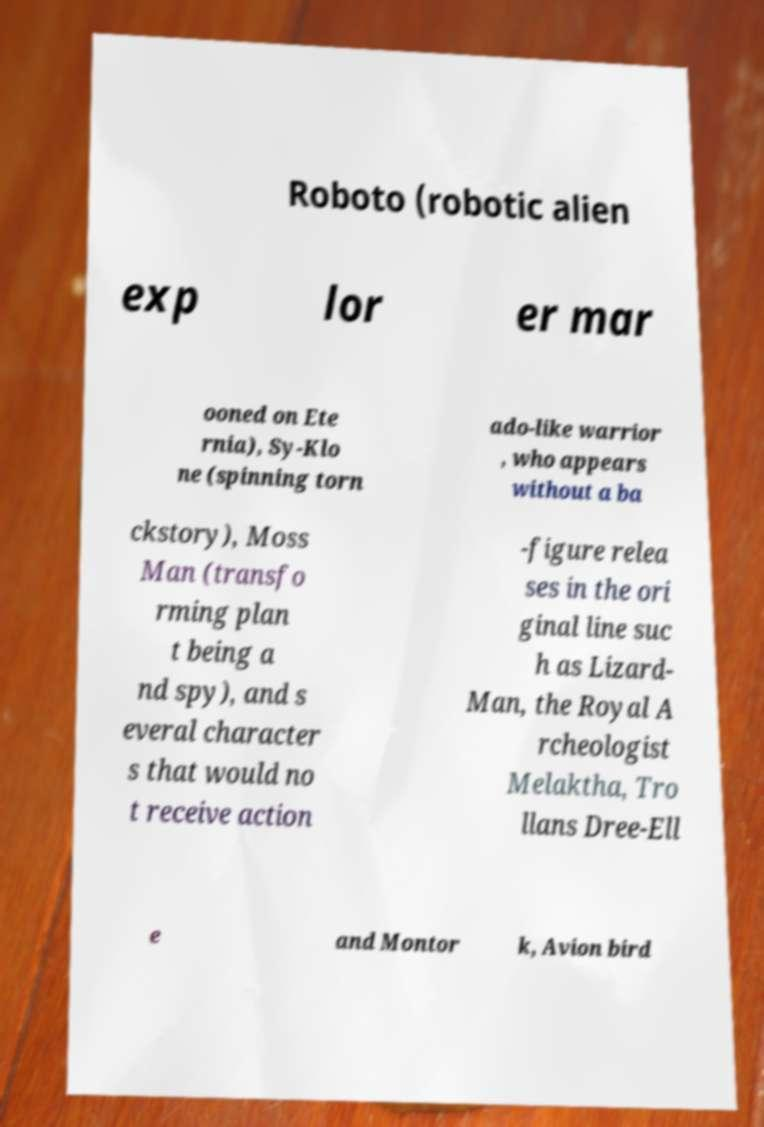There's text embedded in this image that I need extracted. Can you transcribe it verbatim? Roboto (robotic alien exp lor er mar ooned on Ete rnia), Sy-Klo ne (spinning torn ado-like warrior , who appears without a ba ckstory), Moss Man (transfo rming plan t being a nd spy), and s everal character s that would no t receive action -figure relea ses in the ori ginal line suc h as Lizard- Man, the Royal A rcheologist Melaktha, Tro llans Dree-Ell e and Montor k, Avion bird 